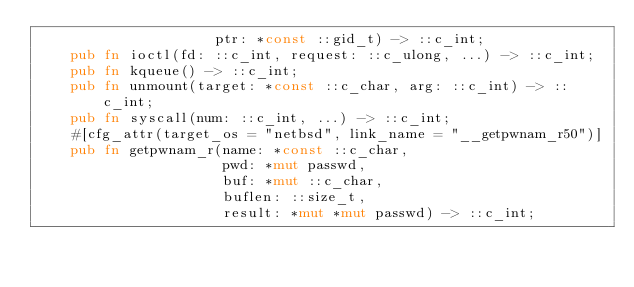Convert code to text. <code><loc_0><loc_0><loc_500><loc_500><_Rust_>                     ptr: *const ::gid_t) -> ::c_int;
    pub fn ioctl(fd: ::c_int, request: ::c_ulong, ...) -> ::c_int;
    pub fn kqueue() -> ::c_int;
    pub fn unmount(target: *const ::c_char, arg: ::c_int) -> ::c_int;
    pub fn syscall(num: ::c_int, ...) -> ::c_int;
    #[cfg_attr(target_os = "netbsd", link_name = "__getpwnam_r50")]
    pub fn getpwnam_r(name: *const ::c_char,
                      pwd: *mut passwd,
                      buf: *mut ::c_char,
                      buflen: ::size_t,
                      result: *mut *mut passwd) -> ::c_int;</code> 